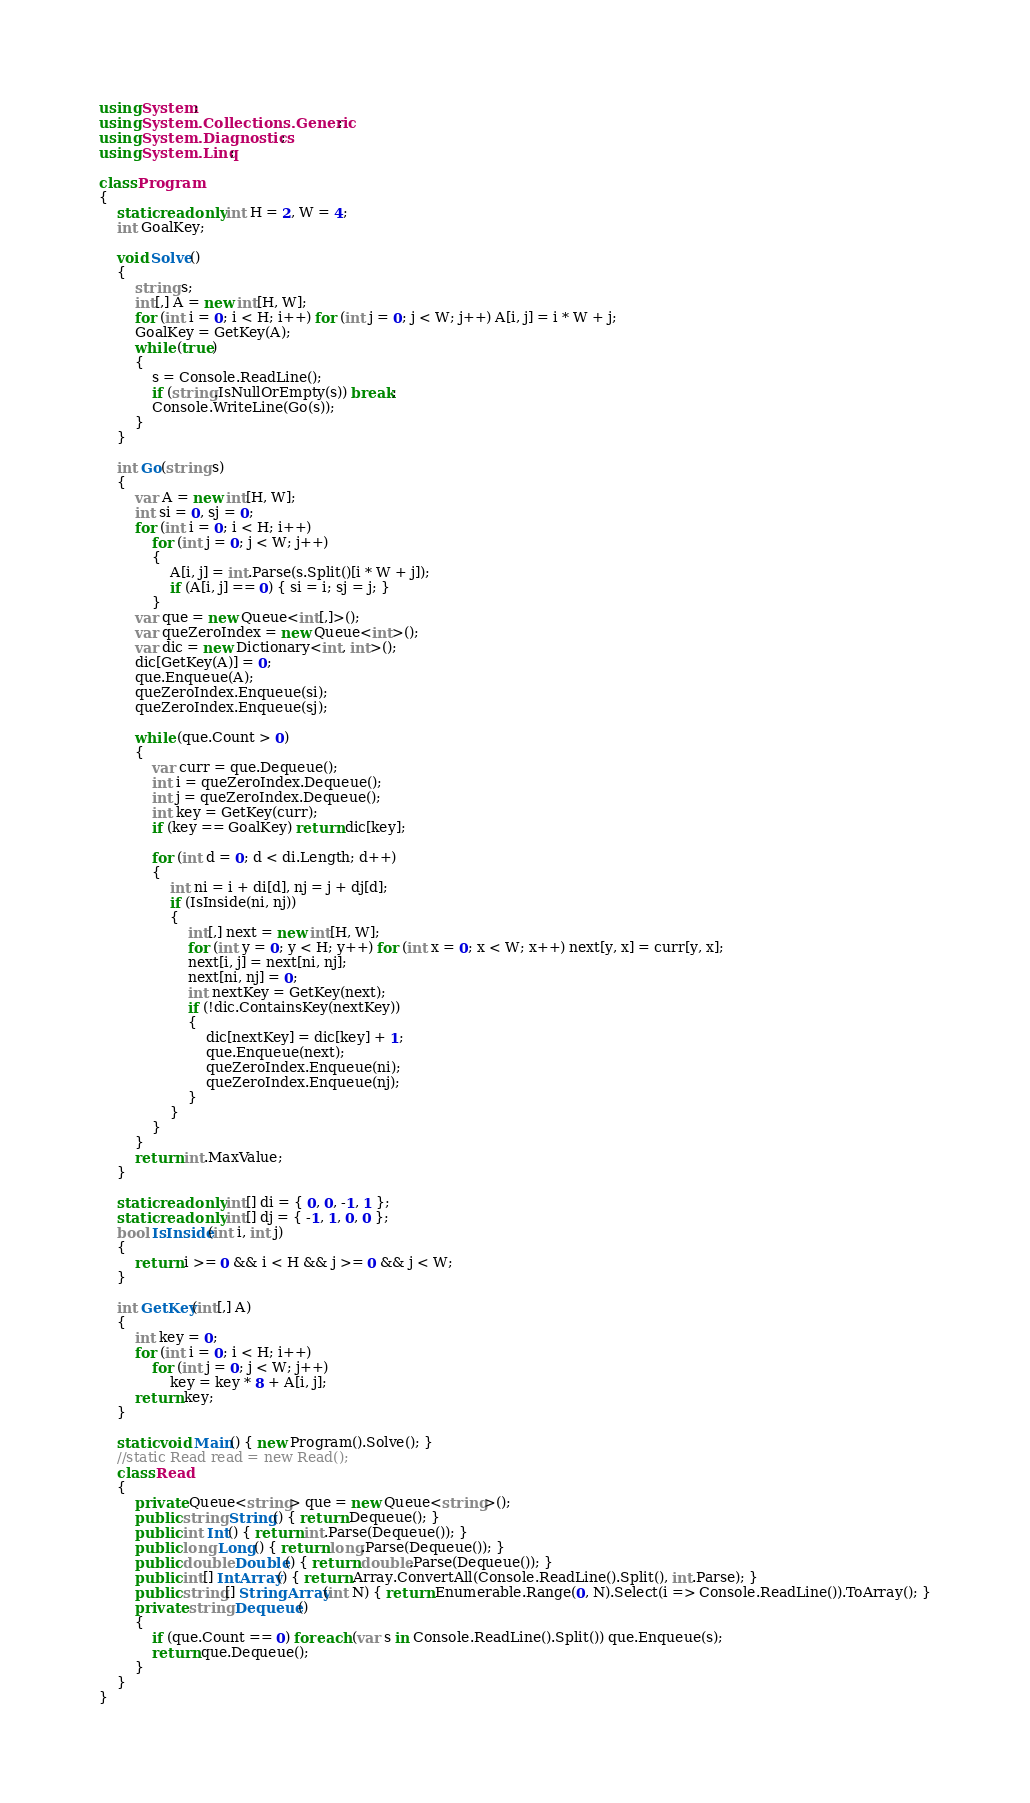Convert code to text. <code><loc_0><loc_0><loc_500><loc_500><_C#_>using System;
using System.Collections.Generic;
using System.Diagnostics;
using System.Linq;

class Program
{
    static readonly int H = 2, W = 4;
    int GoalKey;

    void Solve()
    {
        string s;
        int[,] A = new int[H, W];
        for (int i = 0; i < H; i++) for (int j = 0; j < W; j++) A[i, j] = i * W + j;
        GoalKey = GetKey(A);
        while (true)
        {
            s = Console.ReadLine();
            if (string.IsNullOrEmpty(s)) break;
            Console.WriteLine(Go(s));
        }
    }

    int Go(string s)
    {
        var A = new int[H, W];
        int si = 0, sj = 0;
        for (int i = 0; i < H; i++)
            for (int j = 0; j < W; j++)
            {
                A[i, j] = int.Parse(s.Split()[i * W + j]);
                if (A[i, j] == 0) { si = i; sj = j; }
            }
        var que = new Queue<int[,]>();
        var queZeroIndex = new Queue<int>();
        var dic = new Dictionary<int, int>();
        dic[GetKey(A)] = 0;
        que.Enqueue(A);
        queZeroIndex.Enqueue(si);
        queZeroIndex.Enqueue(sj);

        while (que.Count > 0)
        {
            var curr = que.Dequeue();
            int i = queZeroIndex.Dequeue();
            int j = queZeroIndex.Dequeue();
            int key = GetKey(curr);
            if (key == GoalKey) return dic[key];

            for (int d = 0; d < di.Length; d++)
            {
                int ni = i + di[d], nj = j + dj[d];
                if (IsInside(ni, nj))
                {
                    int[,] next = new int[H, W];
                    for (int y = 0; y < H; y++) for (int x = 0; x < W; x++) next[y, x] = curr[y, x];
                    next[i, j] = next[ni, nj];
                    next[ni, nj] = 0;
                    int nextKey = GetKey(next);
                    if (!dic.ContainsKey(nextKey))
                    {
                        dic[nextKey] = dic[key] + 1;
                        que.Enqueue(next);
                        queZeroIndex.Enqueue(ni);
                        queZeroIndex.Enqueue(nj);
                    }
                }
            }
        }
        return int.MaxValue;
    }

    static readonly int[] di = { 0, 0, -1, 1 };
    static readonly int[] dj = { -1, 1, 0, 0 };
    bool IsInside(int i, int j)
    {
        return i >= 0 && i < H && j >= 0 && j < W;
    }

    int GetKey(int[,] A)
    {
        int key = 0;
        for (int i = 0; i < H; i++)
            for (int j = 0; j < W; j++)
                key = key * 8 + A[i, j];
        return key;
    }

    static void Main() { new Program().Solve(); }
    //static Read read = new Read();
    class Read
    {
        private Queue<string> que = new Queue<string>();
        public string String() { return Dequeue(); }
        public int Int() { return int.Parse(Dequeue()); }
        public long Long() { return long.Parse(Dequeue()); }
        public double Double() { return double.Parse(Dequeue()); }
        public int[] IntArray() { return Array.ConvertAll(Console.ReadLine().Split(), int.Parse); }
        public string[] StringArray(int N) { return Enumerable.Range(0, N).Select(i => Console.ReadLine()).ToArray(); }
        private string Dequeue()
        {
            if (que.Count == 0) foreach (var s in Console.ReadLine().Split()) que.Enqueue(s);
            return que.Dequeue();
        }
    }
}</code> 